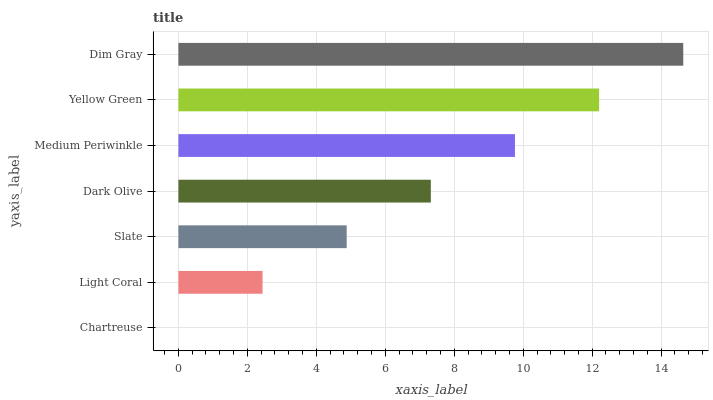Is Chartreuse the minimum?
Answer yes or no. Yes. Is Dim Gray the maximum?
Answer yes or no. Yes. Is Light Coral the minimum?
Answer yes or no. No. Is Light Coral the maximum?
Answer yes or no. No. Is Light Coral greater than Chartreuse?
Answer yes or no. Yes. Is Chartreuse less than Light Coral?
Answer yes or no. Yes. Is Chartreuse greater than Light Coral?
Answer yes or no. No. Is Light Coral less than Chartreuse?
Answer yes or no. No. Is Dark Olive the high median?
Answer yes or no. Yes. Is Dark Olive the low median?
Answer yes or no. Yes. Is Medium Periwinkle the high median?
Answer yes or no. No. Is Light Coral the low median?
Answer yes or no. No. 